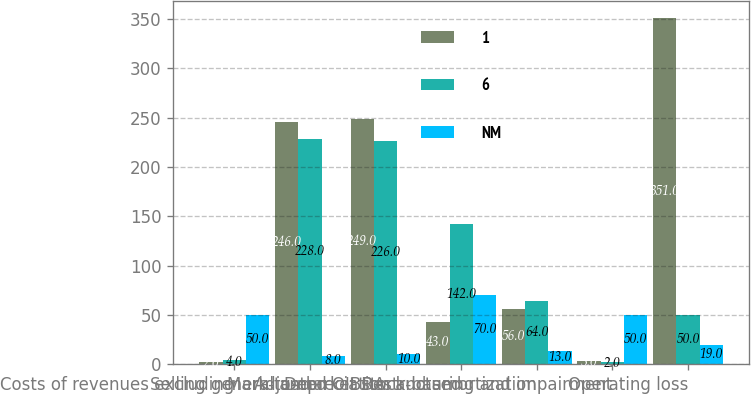Convert chart to OTSL. <chart><loc_0><loc_0><loc_500><loc_500><stacked_bar_chart><ecel><fcel>Costs of revenues excluding<fcel>Selling general and<fcel>Adjusted OIBDA<fcel>Mark-to-market stock-based<fcel>Depreciation and amortization<fcel>Restructuring and impairment<fcel>Operating loss<nl><fcel>1<fcel>2<fcel>246<fcel>249<fcel>43<fcel>56<fcel>3<fcel>351<nl><fcel>6<fcel>4<fcel>228<fcel>226<fcel>142<fcel>64<fcel>2<fcel>50<nl><fcel>NM<fcel>50<fcel>8<fcel>10<fcel>70<fcel>13<fcel>50<fcel>19<nl></chart> 